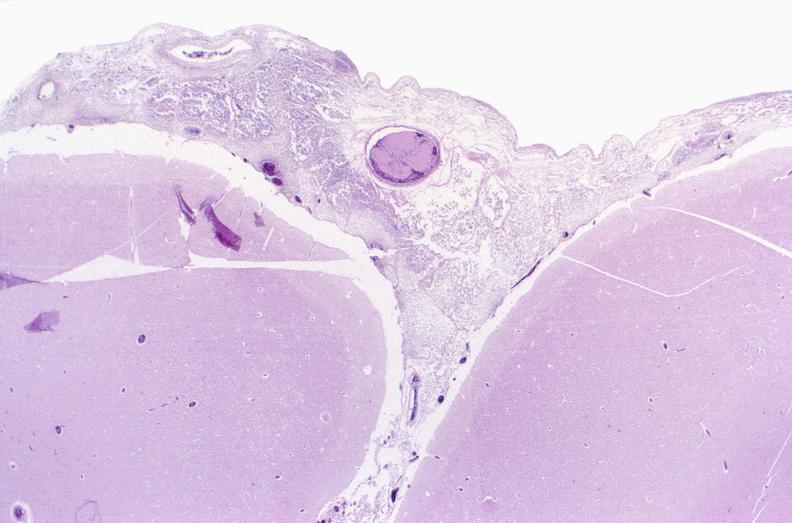what does this image show?
Answer the question using a single word or phrase. Bacterial meningitis 